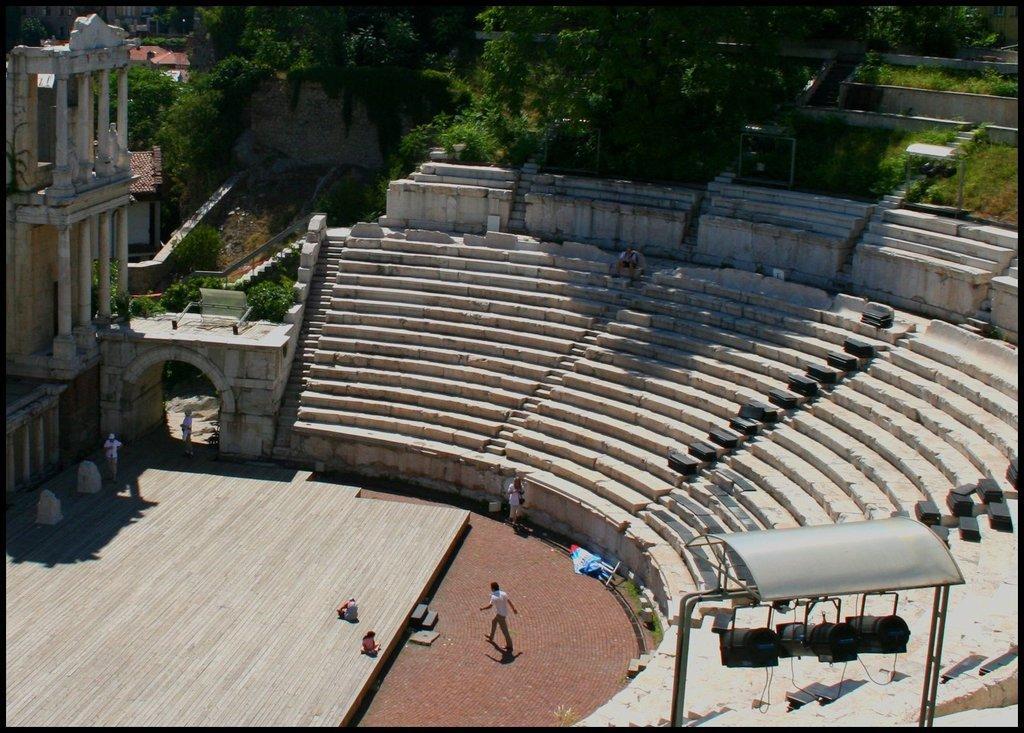Can you describe this image briefly? In this image, there is an outside view. There is a building on the left side of the image. There are some steps in the middle of the image. There are some trees at the top of the image. 